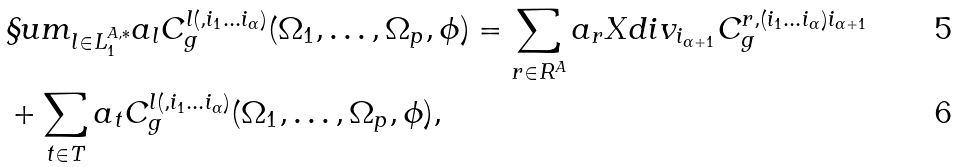<formula> <loc_0><loc_0><loc_500><loc_500>& \S u m _ { l \in L ^ { A , * } _ { 1 } } a _ { l } C ^ { l ( , i _ { 1 } \dots i _ { \alpha } ) } _ { g } ( \Omega _ { 1 } , \dots , \Omega _ { p } , \phi ) = \sum _ { r \in R ^ { A } } a _ { r } X d i v _ { i _ { \alpha + 1 } } C ^ { r , ( i _ { 1 } \dots i _ { \alpha } ) i _ { \alpha + 1 } } _ { g } \\ & + \sum _ { t \in T } a _ { t } C ^ { l ( , i _ { 1 } \dots i _ { \alpha } ) } _ { g } ( \Omega _ { 1 } , \dots , \Omega _ { p } , \phi ) ,</formula> 